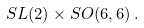Convert formula to latex. <formula><loc_0><loc_0><loc_500><loc_500>S L ( 2 ) \times S O ( 6 , 6 ) \, .</formula> 